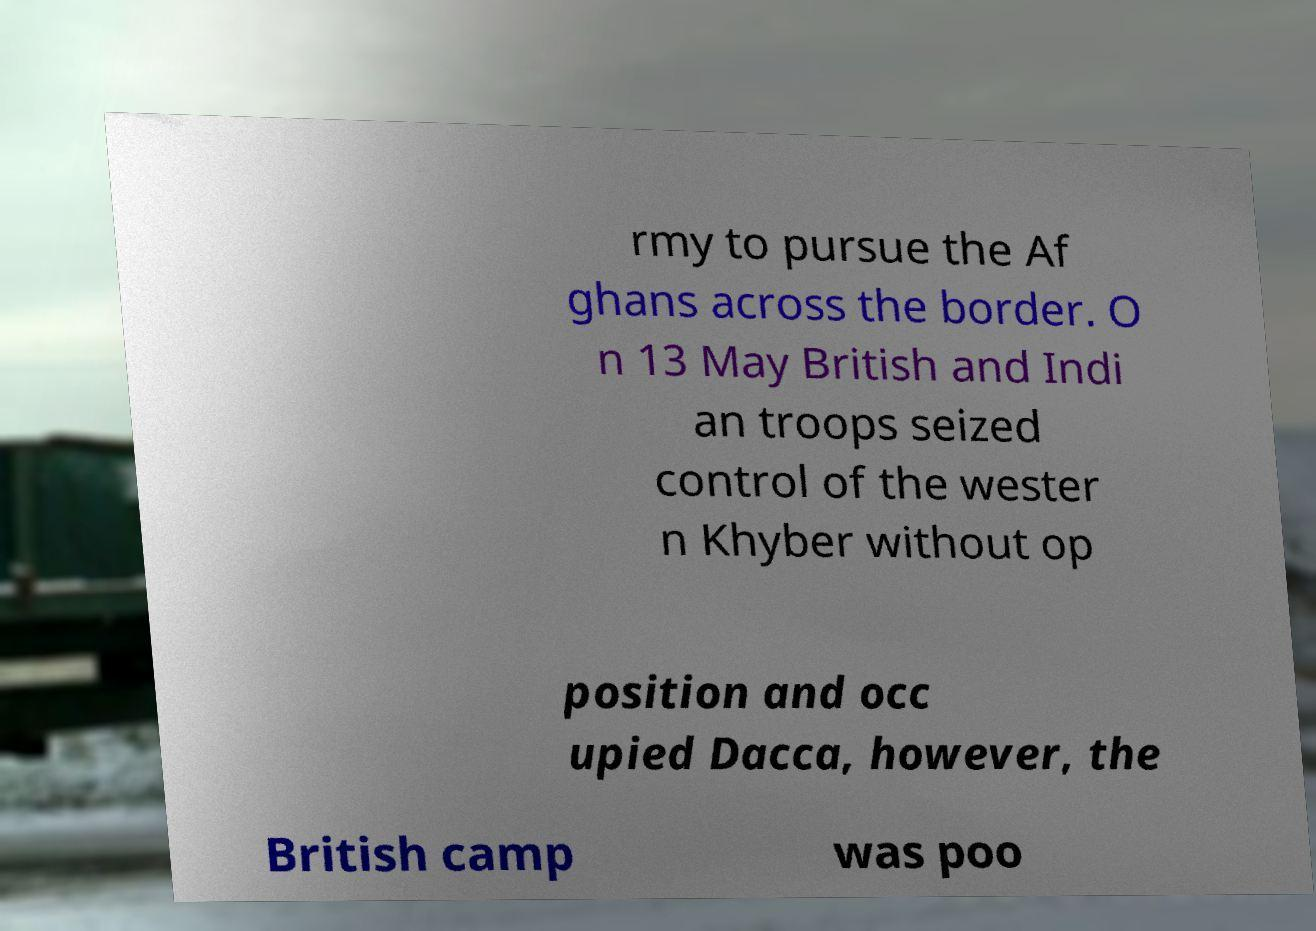Could you extract and type out the text from this image? rmy to pursue the Af ghans across the border. O n 13 May British and Indi an troops seized control of the wester n Khyber without op position and occ upied Dacca, however, the British camp was poo 